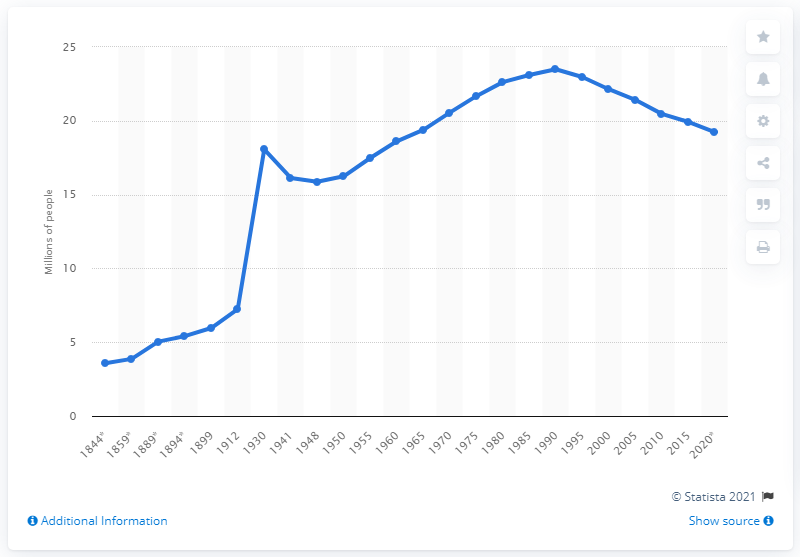Highlight a few significant elements in this photo. In 1930, the population of Romania was 18.06 million. In 2020, the population of Romania is projected to fall to 19.24 million. During the Second World War, Romania suffered significant losses in terms of human life. According to historical records, a total of 18,061 individuals were killed or perished as a result of the war. In 1990, the population of Romania was 23,491,000. In the year 1844, the population of Romania was approximately 3.58 million. 